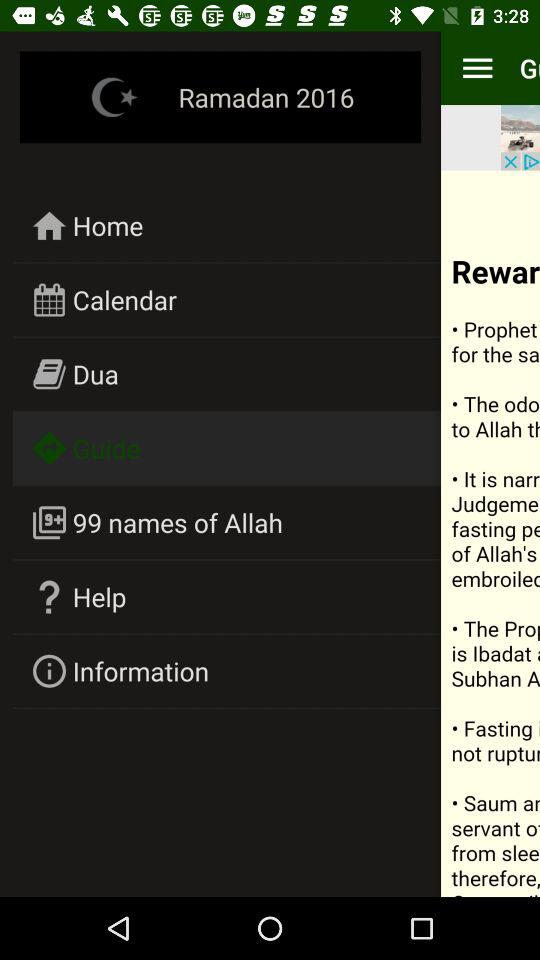What is the year of "Ramadan"? The year is 2016. 